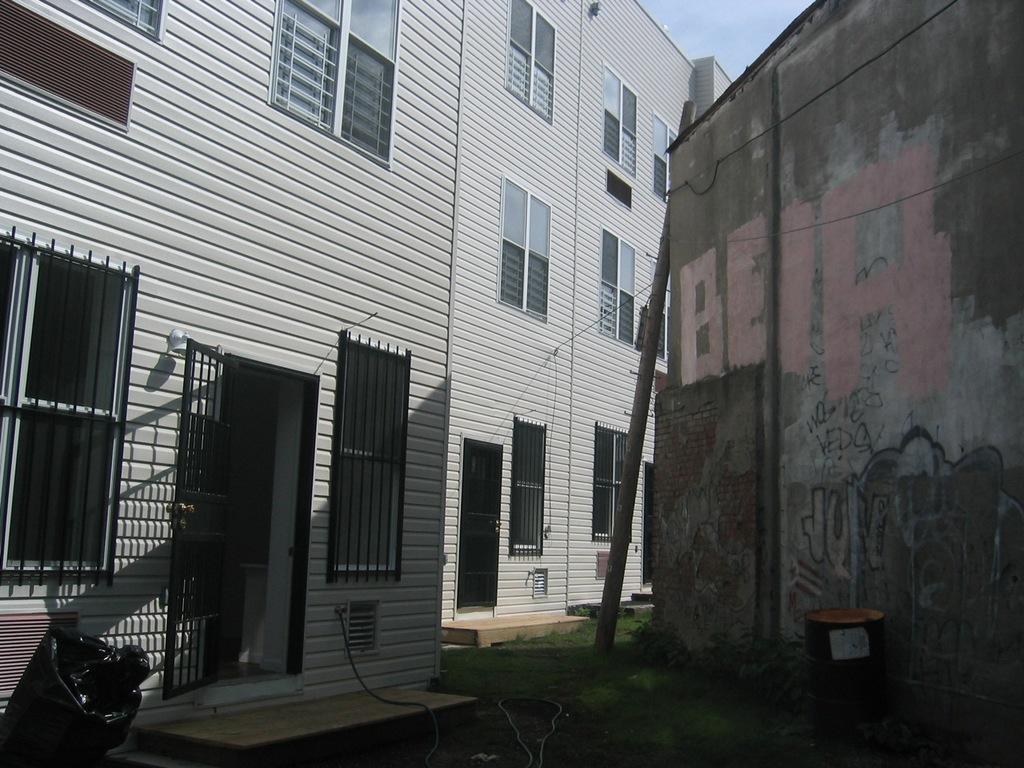What type of structure can be seen in the image? There is a door and windows in the image, which suggests a building. How many buildings are visible in the image? There are buildings in the image, but the exact number is not specified. What is visible in the background of the image? The sky is visible in the image. What type of chair is depicted in the image? There is no chair present in the image. What order are the buildings arranged in the image? The order of the buildings cannot be determined from the image, as their arrangement is not specified. 